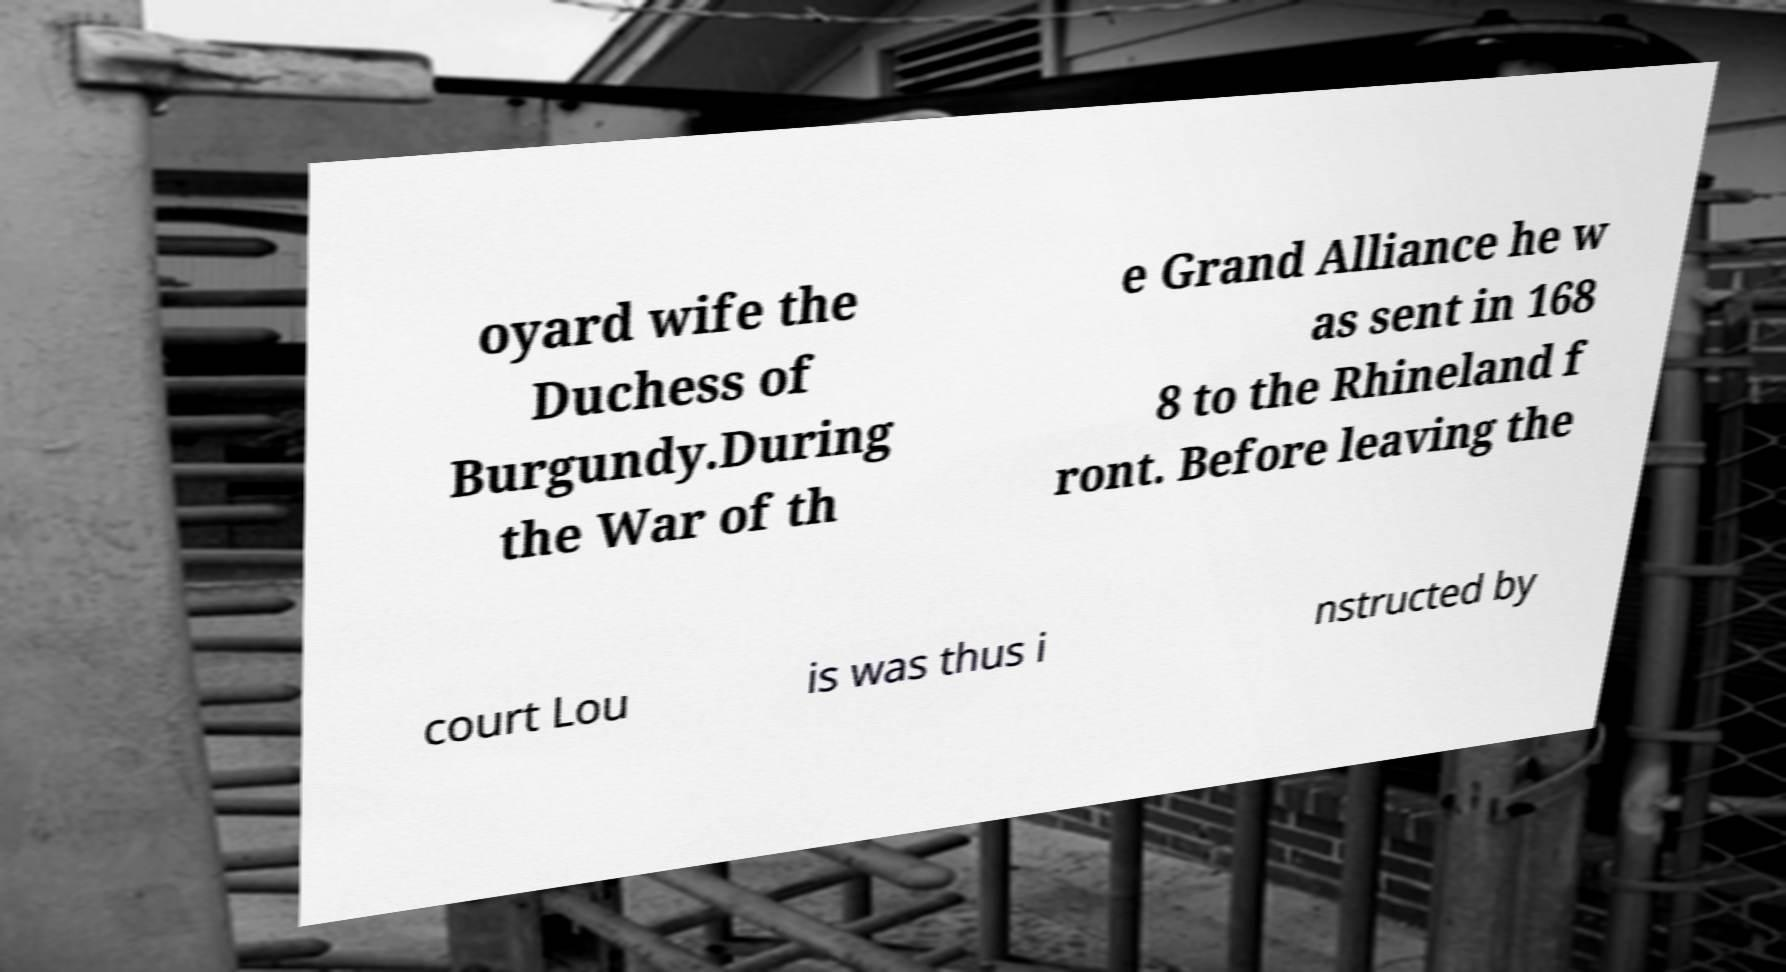There's text embedded in this image that I need extracted. Can you transcribe it verbatim? oyard wife the Duchess of Burgundy.During the War of th e Grand Alliance he w as sent in 168 8 to the Rhineland f ront. Before leaving the court Lou is was thus i nstructed by 